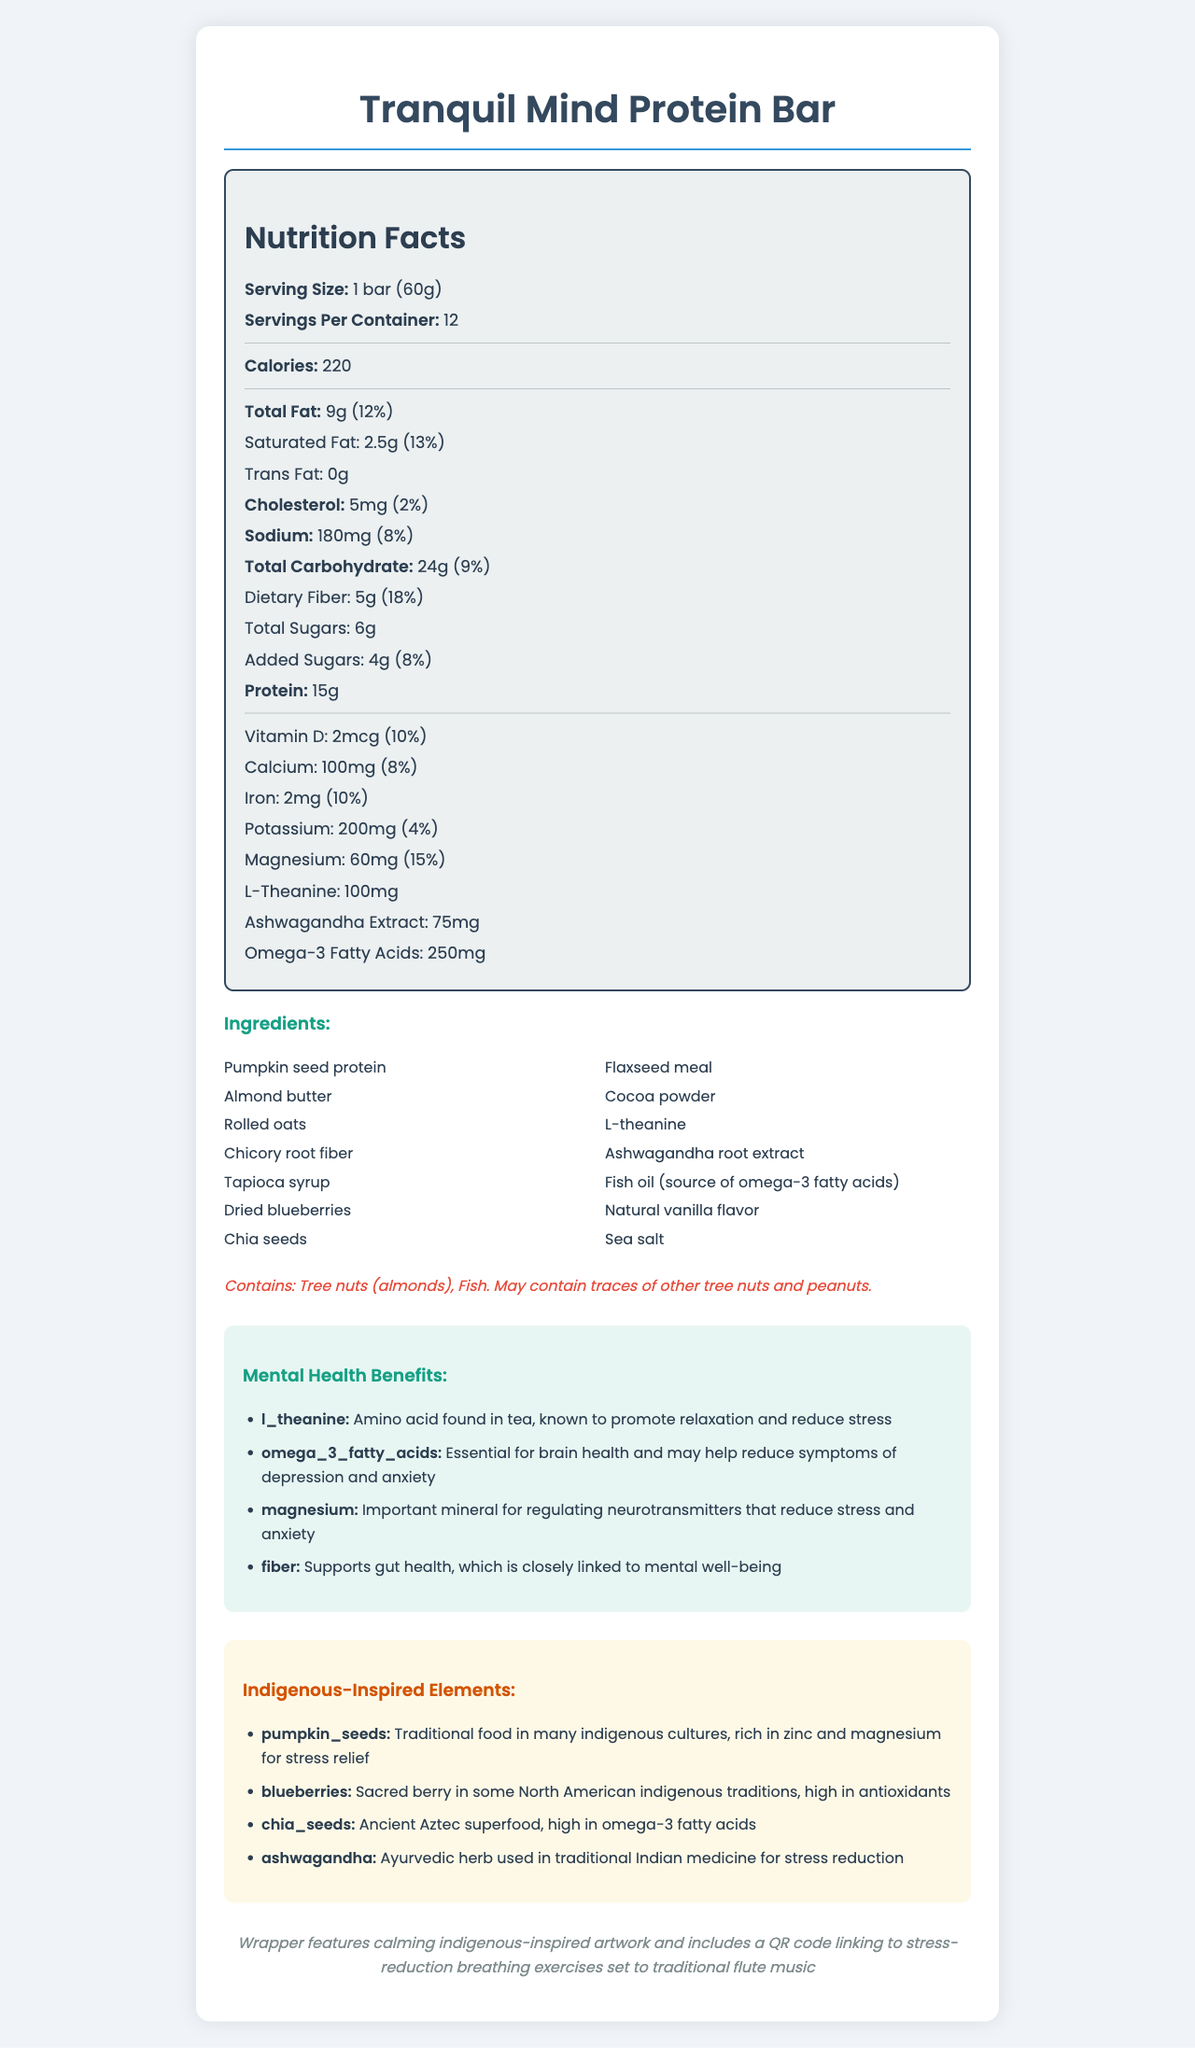what is the serving size of the Tranquil Mind Protein Bar? The serving size is directly mentioned in the Nutrition Facts section as "1 bar (60g)".
Answer: 1 bar (60g) how many calories are in one serving of the protein bar? The calorie count is listed in the Nutrition Facts section as "220".
Answer: 220 how much magnesium is in one serving of the protein bar, and what percentage of the daily value does it provide? The Nutrition Facts section lists magnesium at "60mg" and 15% of the daily value.
Answer: 60mg, 15% name three ingredients in the Tranquil Mind Protein Bar. The ingredients section lists all the ingredients, including Pumpkin seed protein, Almond butter, and Rolled oats among others.
Answer: Pumpkin seed protein, Almond butter, Rolled oats which ingredient is noted for its traditional medicinal use in Ayurveda for stress reduction? Under the Indigenous-Inspired Elements section, ashwagandha is highlighted for its use in traditional Indian medicine for stress reduction.
Answer: Ashwagandha how many servings are there in one container of the protein bar? The Nutrition Facts section states that there are 12 servings per container.
Answer: 12 what is the amount and daily value percentage of dietary fiber per serving? The Nutrition Facts section shows dietary fiber as 5g and the daily value percentage as 18%.
Answer: 5g, 18% which of the following components is specific to promoting relaxation and reducing stress? A. Vitamin D B. L-Theanine C. Omega-3 Fatty Acids Under the Mental Health Benefits section, L-Theanine is noted for promoting relaxation and reducing stress.
Answer: B. L-Theanine which of these is a traditional food in many indigenous cultures, rich in zinc and magnesium? A. Chia seeds B. Blueberries C. Pumpkin seeds Pumpkin seeds are listed under Indigenous-Inspired Elements with a note that they are traditional food in many indigenous cultures and rich in zinc and magnesium.
Answer: C. Pumpkin seeds is there any dairy ingredient in the Tranquil Mind Protein Bar? The ingredients list does not mention any dairy products.
Answer: No describe the mental health benefits provided by the Tranquil Mind Protein Bar. The mental health benefits section details how these ingredients work to support mental health.
Answer: The Tranquil Mind Protein Bar includes ingredients like L-Theanine, Omega-3 Fatty Acids, Magnesium, and fiber, which support mental health by promoting relaxation, reducing symptoms of depression and anxiety, regulating neurotransmitters, and supporting gut health. explain the indigenous-inspired elements found in the Tranquil Mind Protein Bar's ingredients. The Indigenous-Inspired Elements section explains how these ingredients have historical and cultural significance, and their nutritional benefits.
Answer: The bar incorporates traditional ingredients from various indigenous cultures such as pumpkin seeds (rich in zinc and magnesium), blueberries (high in antioxidants), chia seeds (an Aztec superfood rich in omega-3 fatty acids), and ashwagandha (an Ayurvedic herb used for stress reduction). how much omega-3 fatty acids are in one serving of the protein bar? The amount of omega-3 fatty acids is indicated in the Nutrition Facts section as 250mg.
Answer: 250mg what visual feature on the packaging helps with stress reduction exercises? The Packaging Notes section mentions the QR code on the wrapper which links to stress-reduction exercises set to flute music.
Answer: A QR code linking to stress-reduction breathing exercises set to traditional flute music what type of artwork is featured on the wrapper of the Tranquil Mind Protein Bar? The Packaging Notes mention indigenous-inspired artwork featured on the wrapper.
Answer: Indigenous-inspired artwork how much cholesterol is in one serving of the protein bar, and what percentage of the daily value does it represent? The Nutrition Facts indicate that each serving contains 5mg of cholesterol and it represents 2% of the daily value.
Answer: 5mg, 2% what is the total amount of sugars in one serving of the protein bar? The Nutrition Facts section lists total sugars as 6g.
Answer: 6g which of the following mental health benefits is not mentioned for the ingredients in the Tranquil Mind Protein Bar? A. Boosting immune function B. Reducing stress C. Supporting gut health The Mental Health Benefits section mentions reducing stress, promoting relaxation, and supporting gut health but does not mention boosting immune function.
Answer: A. Boosting immune function what is the primary purpose of including L-Theanine in the Tranquil Mind Protein Bar? The Mental Health Benefits section states that L-Theanine is included to promote relaxation and reduce stress.
Answer: To promote relaxation and reduce stress which ingredients might people with tree nut allergies need to avoid? The Allergen Information section states that the bar contains tree nuts (almonds) and may contain traces of other tree nuts and peanuts.
Answer: Almond butter, and possibly traces of other tree nuts and peanuts what traditional medicinal system is associated with the use of Ashwagandha? The Indigenous-Inspired Elements section mentions Ashwagandha's use in traditional Indian medicine for stress reduction.
Answer: Traditional Indian medicine (Ayurveda) summarize the key features of the Tranquil Mind Protein Bar as described in the document. The document provides detailed nutritional information, ingredient lists, mental health benefits, and highlights the use of culturally significant ingredients combined with modern dietary needs, centered on promoting mental well-being and honoring indigenous traditions.
Answer: The Tranquil Mind Protein Bar is designed to support mental health and stress reduction, featuring ingredients inspired by indigenous cultures and traditional medicine. It provides various nutrients beneficial for mental health, like L-Theanine, Omega-3s, Magnesium, and fiber. The bar has 220 calories per serving, with 15g of protein and significant amounts of dietary fiber, magnesium, and omega-3s. The packaging includes indigenous-inspired artwork and a QR code linking to stress-reduction exercises. what is the amino acid found in the Tranquil Mind Protein Bar that promotes relaxation and reduces stress? The Mental Health Benefits section mentions that L-Theanine is known to promote relaxation and reduce stress.
Answer: L-Theanine 